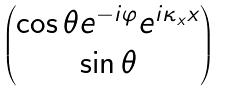Convert formula to latex. <formula><loc_0><loc_0><loc_500><loc_500>\begin{pmatrix} \cos \theta e ^ { - i \varphi } e ^ { i { \kappa _ { x } x } } \\ \sin \theta \end{pmatrix}</formula> 